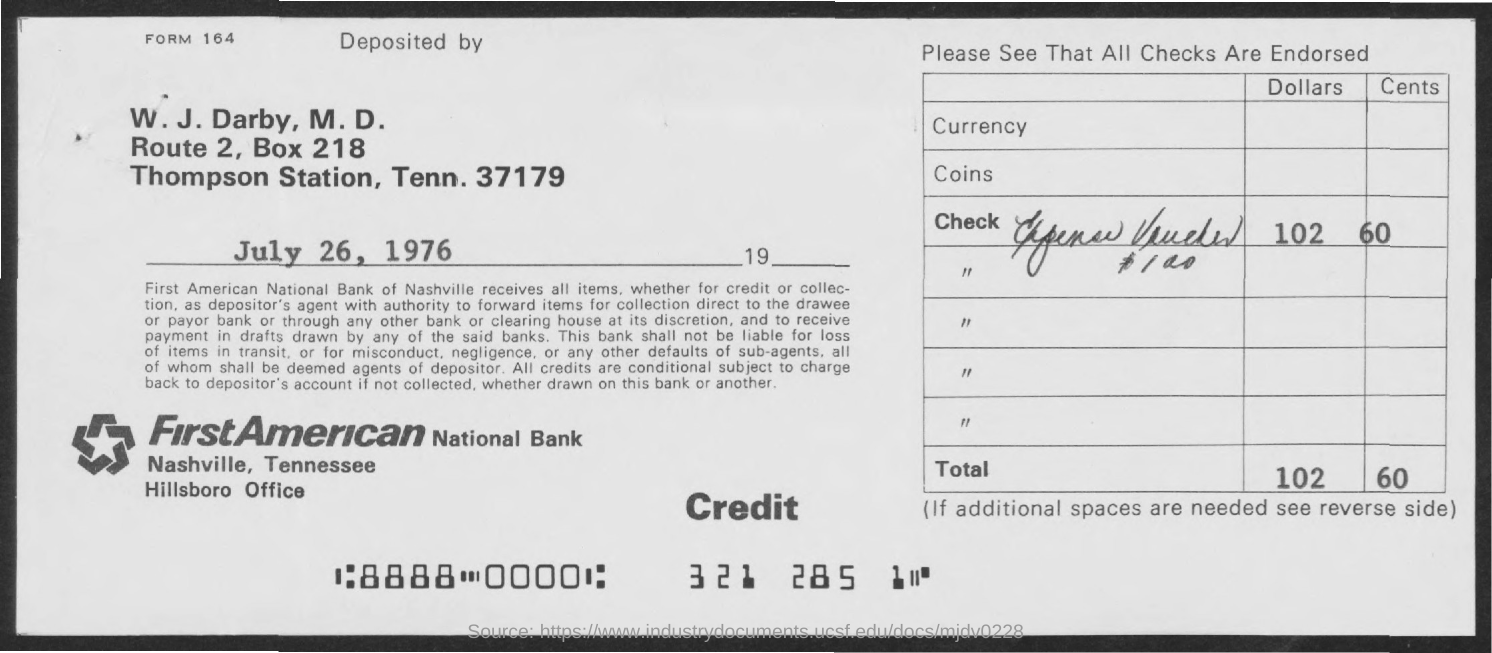What is the date of deposit?
Give a very brief answer. July 26, 1976. What is the total amount ?
Provide a succinct answer. 102.60. What is the form no.?
Offer a terse response. 164. 